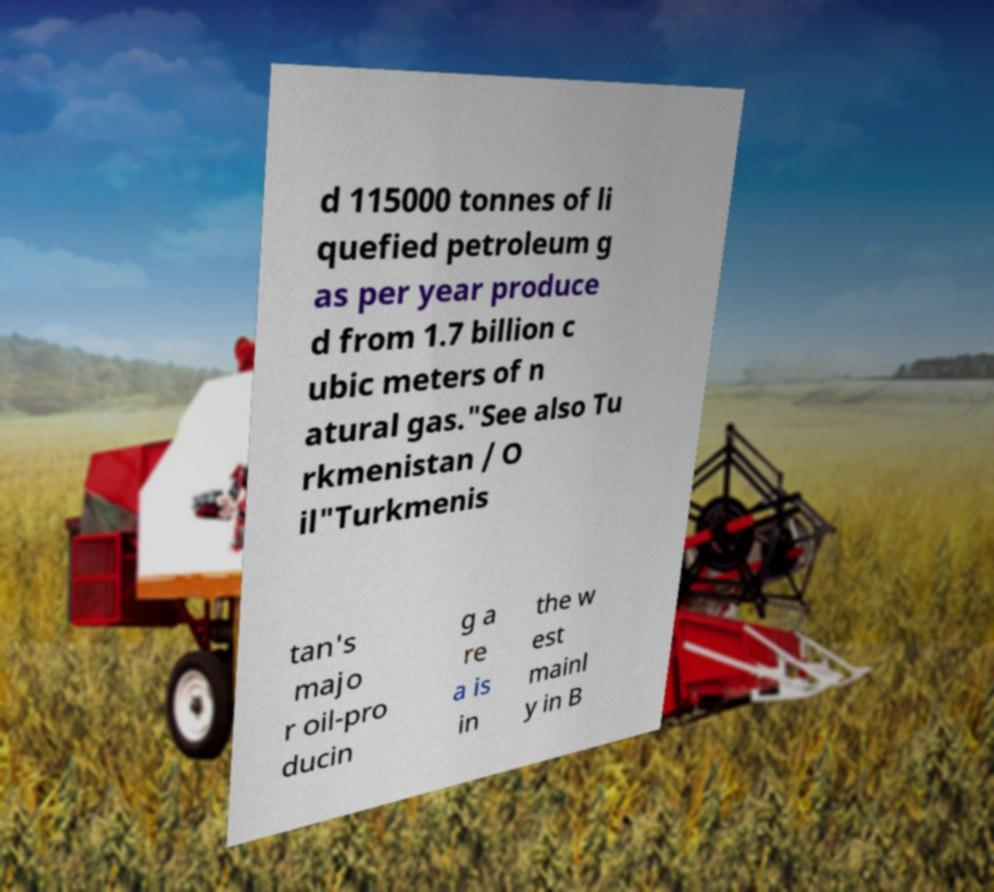I need the written content from this picture converted into text. Can you do that? d 115000 tonnes of li quefied petroleum g as per year produce d from 1.7 billion c ubic meters of n atural gas."See also Tu rkmenistan / O il"Turkmenis tan's majo r oil-pro ducin g a re a is in the w est mainl y in B 